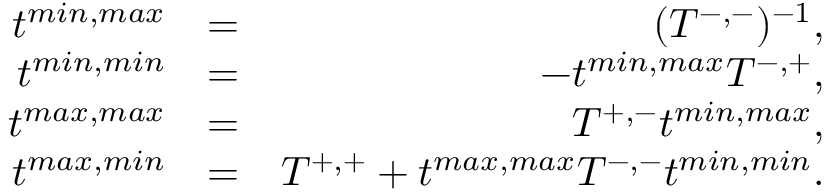Convert formula to latex. <formula><loc_0><loc_0><loc_500><loc_500>\begin{array} { r l r } { t ^ { \min , \max } } & { = } & { ( T ^ { - , - } ) ^ { - 1 } , } \\ { t ^ { \min , \min } } & { = } & { - t ^ { \min , \max } T ^ { - , + } , } \\ { t ^ { \max , \max } } & { = } & { T ^ { + , - } t ^ { \min , \max } , } \\ { t ^ { \max , \min } } & { = } & { T ^ { + , + } + t ^ { \max , \max } T ^ { - , - } t ^ { \min , \min } . } \end{array}</formula> 